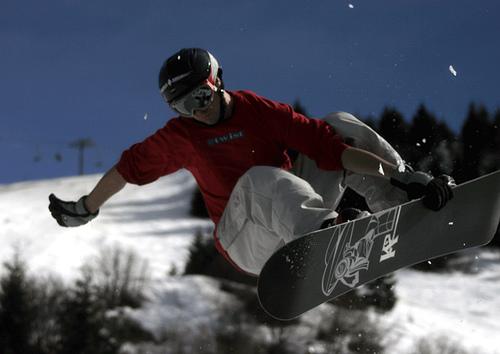What material is the snowboard made up of?
Concise answer only. Wood. What sport is he doing?
Be succinct. Snowboarding. Why does he have a helmet?
Be succinct. Safety. 